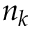<formula> <loc_0><loc_0><loc_500><loc_500>n _ { k }</formula> 